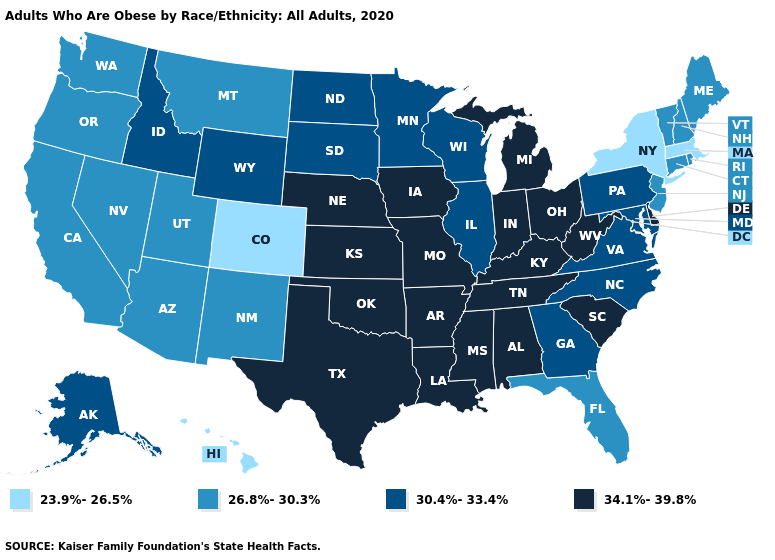What is the highest value in the West ?
Concise answer only. 30.4%-33.4%. What is the value of West Virginia?
Short answer required. 34.1%-39.8%. Name the states that have a value in the range 23.9%-26.5%?
Answer briefly. Colorado, Hawaii, Massachusetts, New York. Does the first symbol in the legend represent the smallest category?
Write a very short answer. Yes. What is the highest value in states that border Minnesota?
Answer briefly. 34.1%-39.8%. What is the lowest value in the USA?
Be succinct. 23.9%-26.5%. What is the value of Iowa?
Concise answer only. 34.1%-39.8%. Which states hav the highest value in the South?
Give a very brief answer. Alabama, Arkansas, Delaware, Kentucky, Louisiana, Mississippi, Oklahoma, South Carolina, Tennessee, Texas, West Virginia. Name the states that have a value in the range 26.8%-30.3%?
Quick response, please. Arizona, California, Connecticut, Florida, Maine, Montana, Nevada, New Hampshire, New Jersey, New Mexico, Oregon, Rhode Island, Utah, Vermont, Washington. What is the lowest value in states that border Iowa?
Concise answer only. 30.4%-33.4%. What is the highest value in the West ?
Concise answer only. 30.4%-33.4%. Does the first symbol in the legend represent the smallest category?
Answer briefly. Yes. Name the states that have a value in the range 30.4%-33.4%?
Concise answer only. Alaska, Georgia, Idaho, Illinois, Maryland, Minnesota, North Carolina, North Dakota, Pennsylvania, South Dakota, Virginia, Wisconsin, Wyoming. What is the value of Minnesota?
Quick response, please. 30.4%-33.4%. Name the states that have a value in the range 34.1%-39.8%?
Keep it brief. Alabama, Arkansas, Delaware, Indiana, Iowa, Kansas, Kentucky, Louisiana, Michigan, Mississippi, Missouri, Nebraska, Ohio, Oklahoma, South Carolina, Tennessee, Texas, West Virginia. 